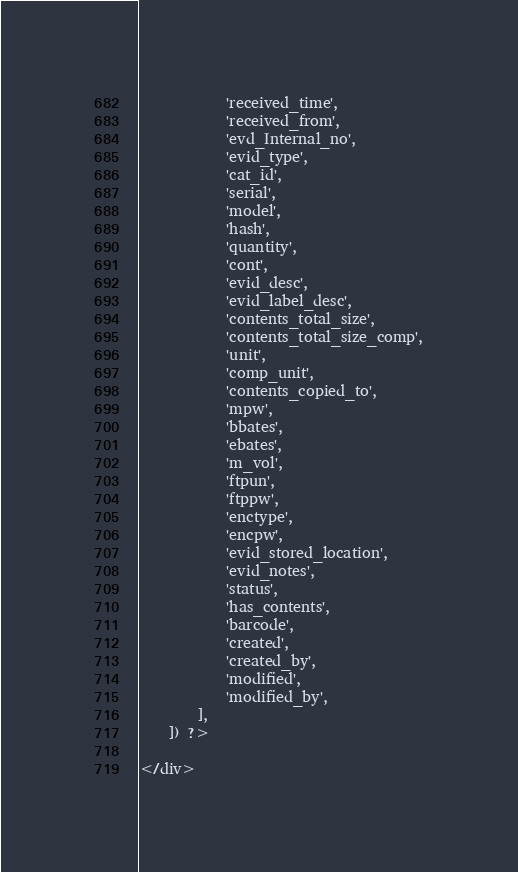<code> <loc_0><loc_0><loc_500><loc_500><_PHP_>            'received_time',
            'received_from',
            'evd_Internal_no',
            'evid_type',
            'cat_id',
            'serial',
            'model',
            'hash',
            'quantity',
            'cont',
            'evid_desc',
            'evid_label_desc',
            'contents_total_size',
            'contents_total_size_comp',
            'unit',
            'comp_unit',
            'contents_copied_to',
            'mpw',
            'bbates',
            'ebates',
            'm_vol',
            'ftpun',
            'ftppw',
            'enctype',
            'encpw',
            'evid_stored_location',
            'evid_notes',
            'status',
            'has_contents',
            'barcode',
            'created',
            'created_by',
            'modified',
            'modified_by',
        ],
    ]) ?>

</div>
</code> 